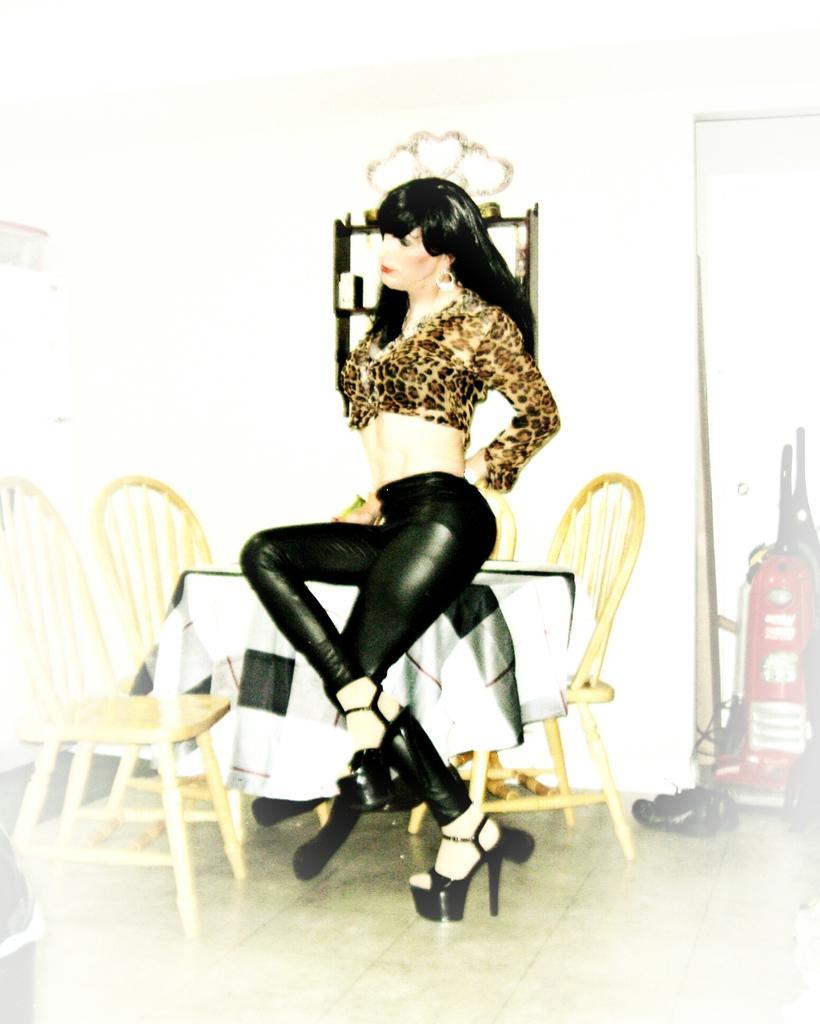Please provide a concise description of this image. there is room and there is one table and 4 chairs around the table and one woman is sitting on the table and she is wearing black pant and yellow top and also wearing the shoes and also she is wearing the earrings and the wall has small table and there are some other shoes. 